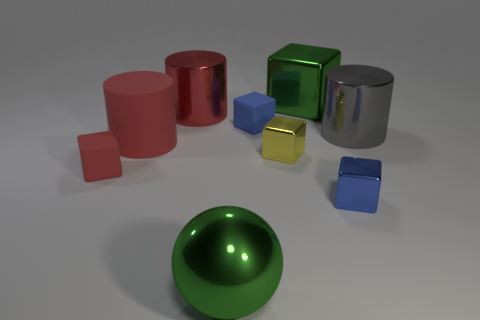Subtract all green cubes. How many cubes are left? 4 Subtract all large blocks. How many blocks are left? 4 Subtract all green cubes. Subtract all blue spheres. How many cubes are left? 4 Add 1 cubes. How many objects exist? 10 Subtract all blocks. How many objects are left? 4 Add 7 gray metallic objects. How many gray metallic objects are left? 8 Add 8 large purple metal cylinders. How many large purple metal cylinders exist? 8 Subtract 1 green spheres. How many objects are left? 8 Subtract all shiny spheres. Subtract all big green shiny spheres. How many objects are left? 7 